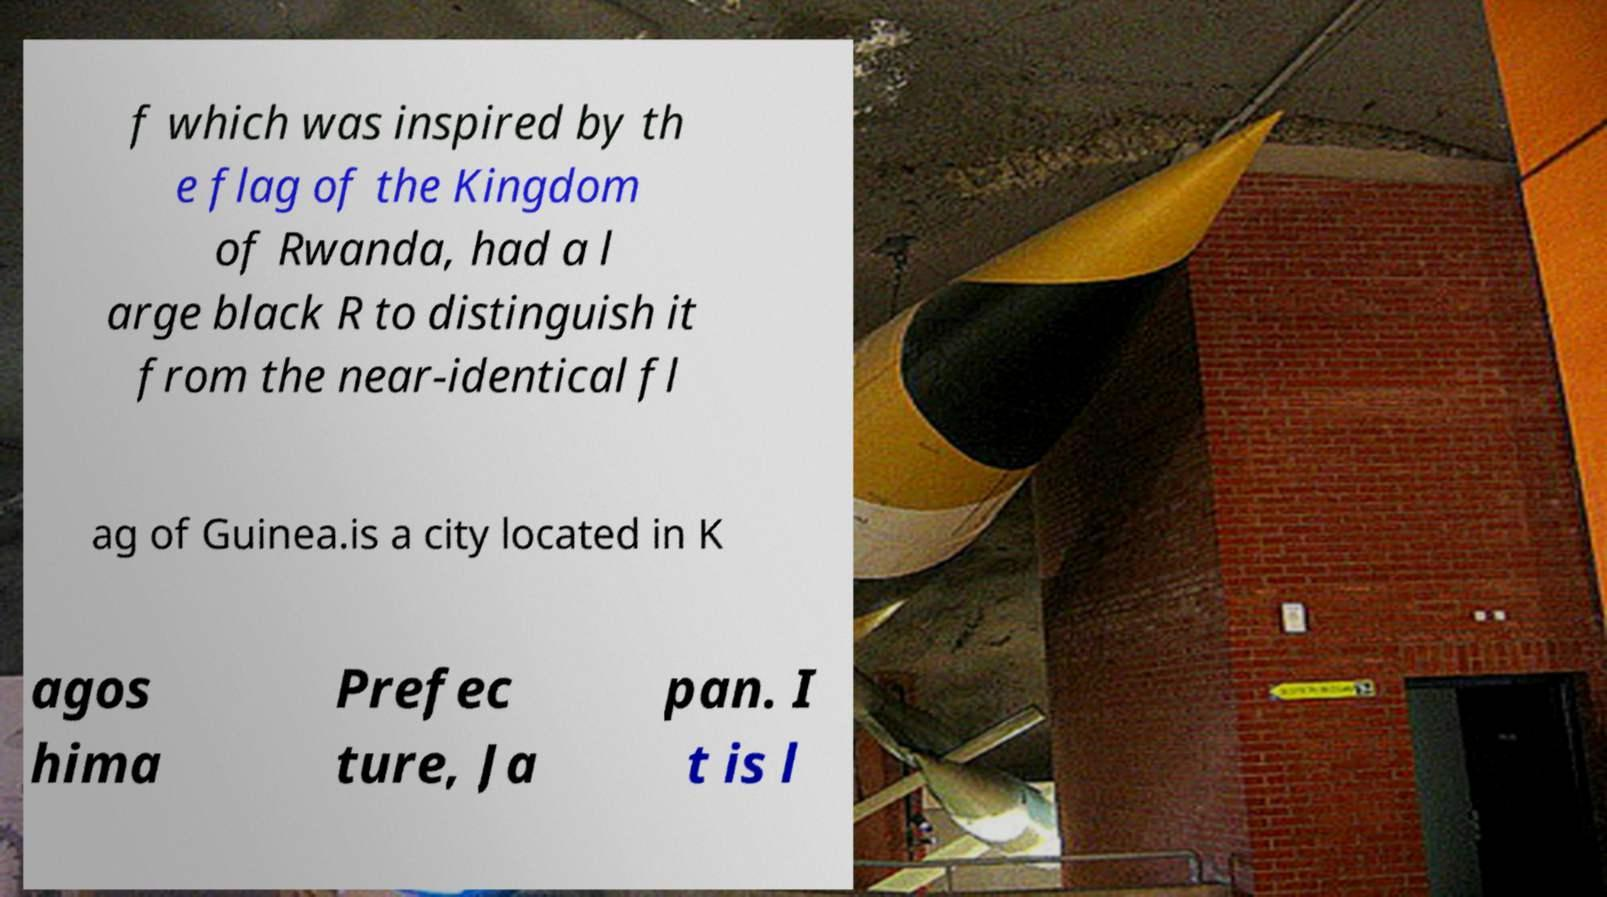There's text embedded in this image that I need extracted. Can you transcribe it verbatim? f which was inspired by th e flag of the Kingdom of Rwanda, had a l arge black R to distinguish it from the near-identical fl ag of Guinea.is a city located in K agos hima Prefec ture, Ja pan. I t is l 